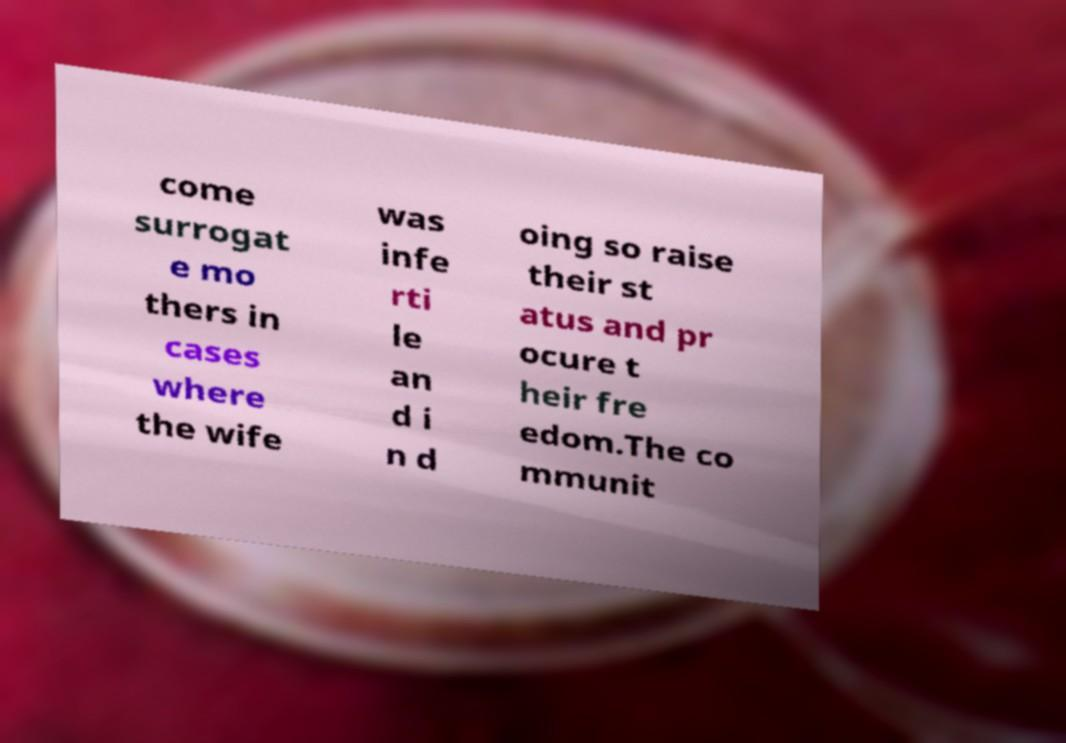Please read and relay the text visible in this image. What does it say? come surrogat e mo thers in cases where the wife was infe rti le an d i n d oing so raise their st atus and pr ocure t heir fre edom.The co mmunit 